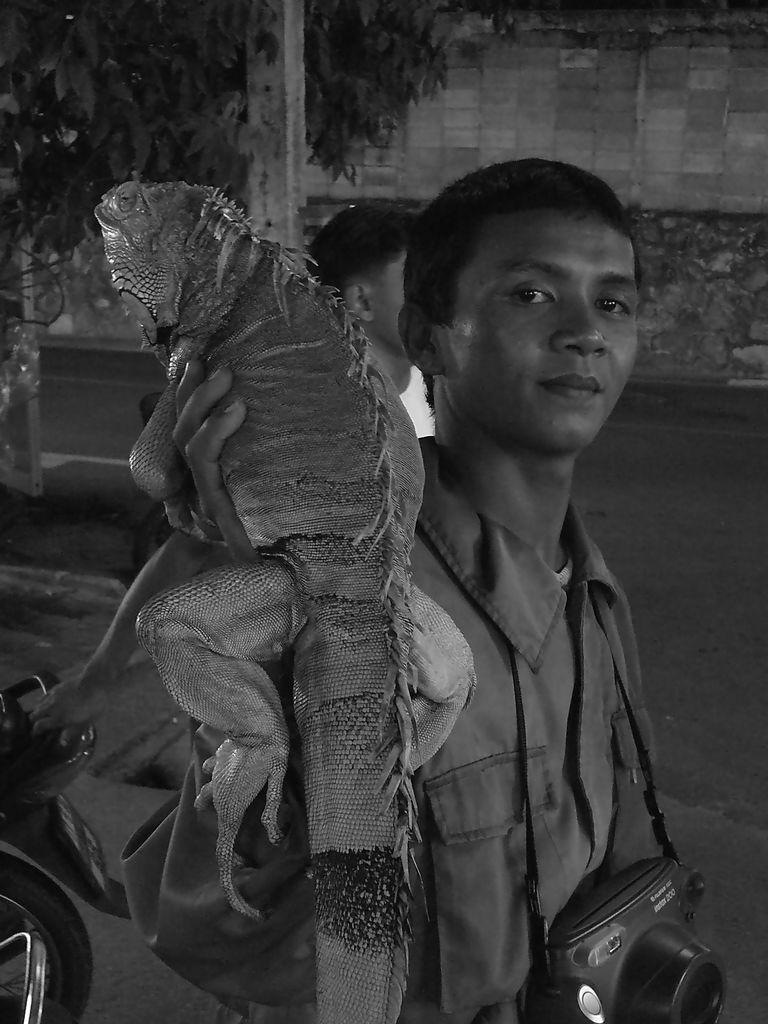Can you describe this image briefly? In this image, In the middle there is a man standing and he is carrying a camera which is in black color, He is holding a object in his right hand, In the background there is a person walking and there is a tree which is in green color. 